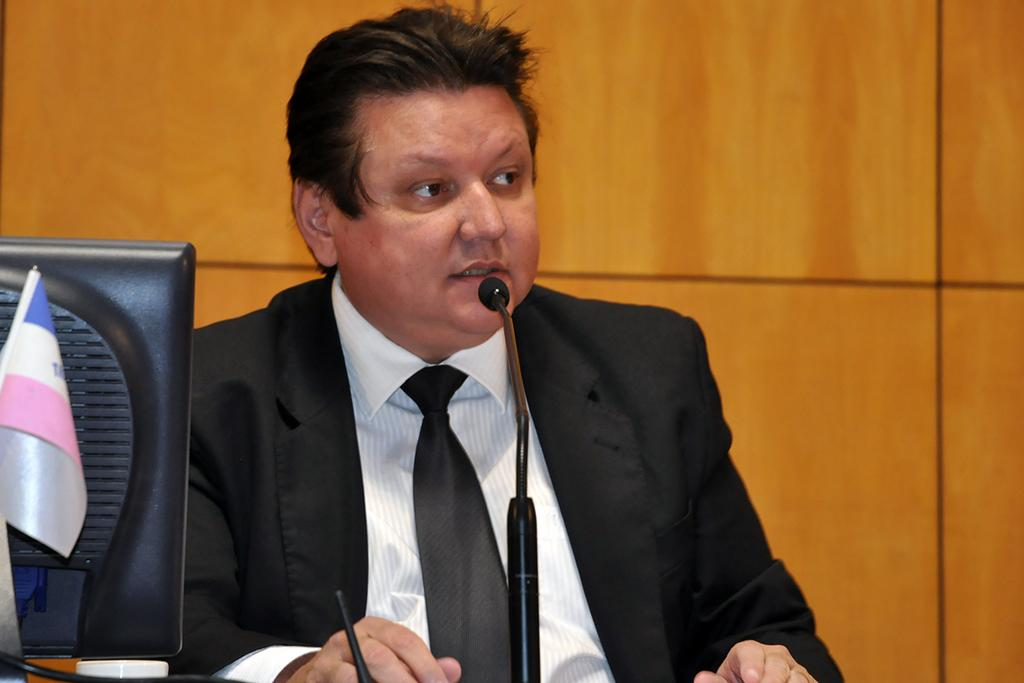Who is the main subject in the image? There is a person in the center of the image. What is the person wearing? The person is wearing a tie. What is the person doing in the image? The person is sitting. What objects are in the front of the image? There is a monitor, a flag, and a mic in the front of the image. What can be seen in the background of the image? There is a wall in the background of the image. What type of song is being played by the moon in the image? There is no moon present in the image, and therefore no song can be played by it. What is the person using the sticks for in the image? There are no sticks present in the image, so it is not possible to determine what they might be used for. 